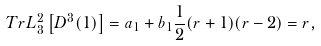Convert formula to latex. <formula><loc_0><loc_0><loc_500><loc_500>T r L ^ { 2 } _ { 3 } \left [ D ^ { 3 } ( 1 ) \right ] = a _ { 1 } + b _ { 1 } \frac { 1 } { 2 } ( r + 1 ) ( r - 2 ) = r ,</formula> 